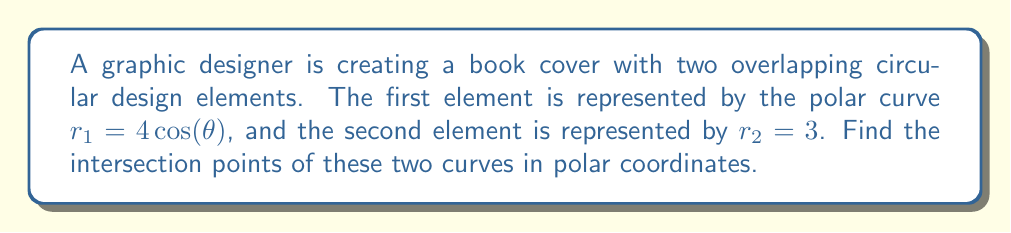Show me your answer to this math problem. To find the intersection points of the two polar curves, we need to solve the equation:

$$4\cos(\theta) = 3$$

Let's solve this step-by-step:

1) First, isolate $\cos(\theta)$:
   $$\cos(\theta) = \frac{3}{4}$$

2) To find $\theta$, we need to use the inverse cosine function (arccos):
   $$\theta = \arccos(\frac{3}{4})$$

3) The arccos function returns values in the range $[0, \pi]$. In this case:
   $$\theta_1 = \arccos(\frac{3}{4}) \approx 0.7227 \text{ radians}$$

4) However, due to the symmetry of the cosine function, there's a second solution in the range $[-\pi, \pi]$:
   $$\theta_2 = -\arccos(\frac{3}{4}) \approx -0.7227 \text{ radians}$$

5) To get the $r$ coordinate, we can use either equation. Let's use $r_2 = 3$.

Therefore, the two intersection points in polar coordinates are:
$(3, 0.7227)$ and $(3, -0.7227)$

[asy]
import graph;
size(200);
real r(real t) {return 4*cos(t);}
draw(polargraph(r,0,pi,operator ..),blue);
draw(polargraph(r,-pi,0,operator ..),blue);
draw(Circle((0,0),3),red);
dot((3*cos(0.7227),3*sin(0.7227)),darkgreen);
dot((3*cos(-0.7227),3*sin(-0.7227)),darkgreen);
label("$r_1=4\cos(\theta)$",(2,2),NE,blue);
label("$r_2=3$",(0,3),N,red);
[/asy]
Answer: The intersection points are $(3, 0.7227)$ and $(3, -0.7227)$ in polar coordinates. 